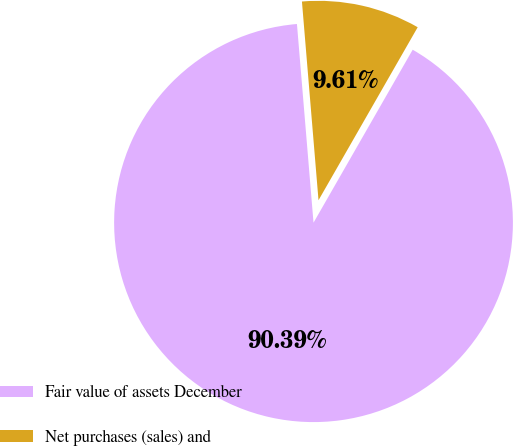<chart> <loc_0><loc_0><loc_500><loc_500><pie_chart><fcel>Fair value of assets December<fcel>Net purchases (sales) and<nl><fcel>90.39%<fcel>9.61%<nl></chart> 